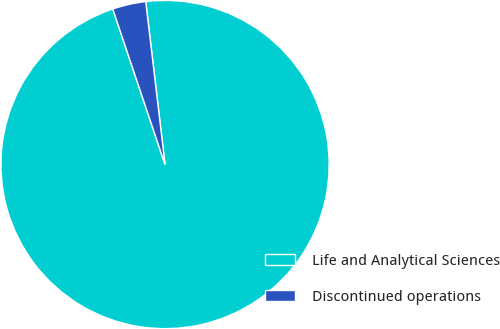Convert chart. <chart><loc_0><loc_0><loc_500><loc_500><pie_chart><fcel>Life and Analytical Sciences<fcel>Discontinued operations<nl><fcel>96.72%<fcel>3.28%<nl></chart> 